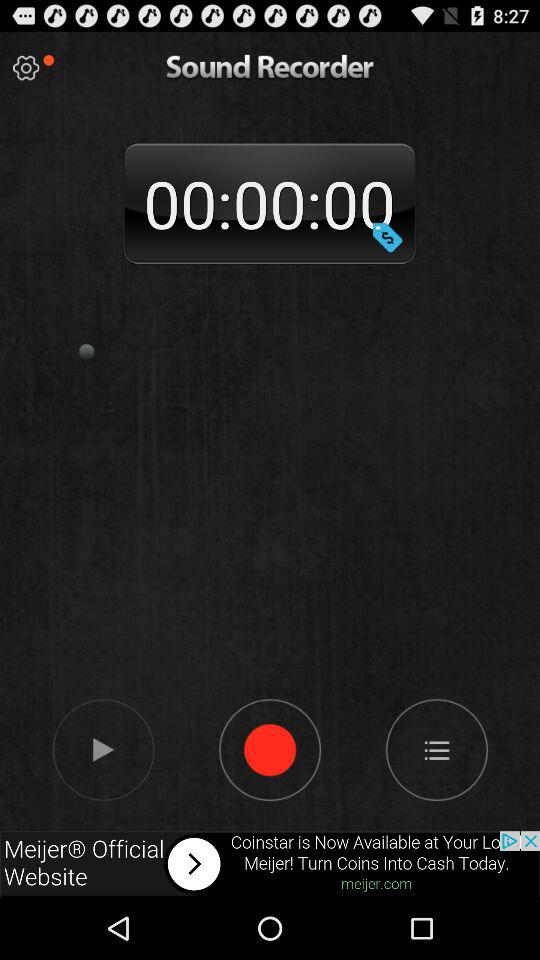How many tracks have been recorded?
When the provided information is insufficient, respond with <no answer>. <no answer> 